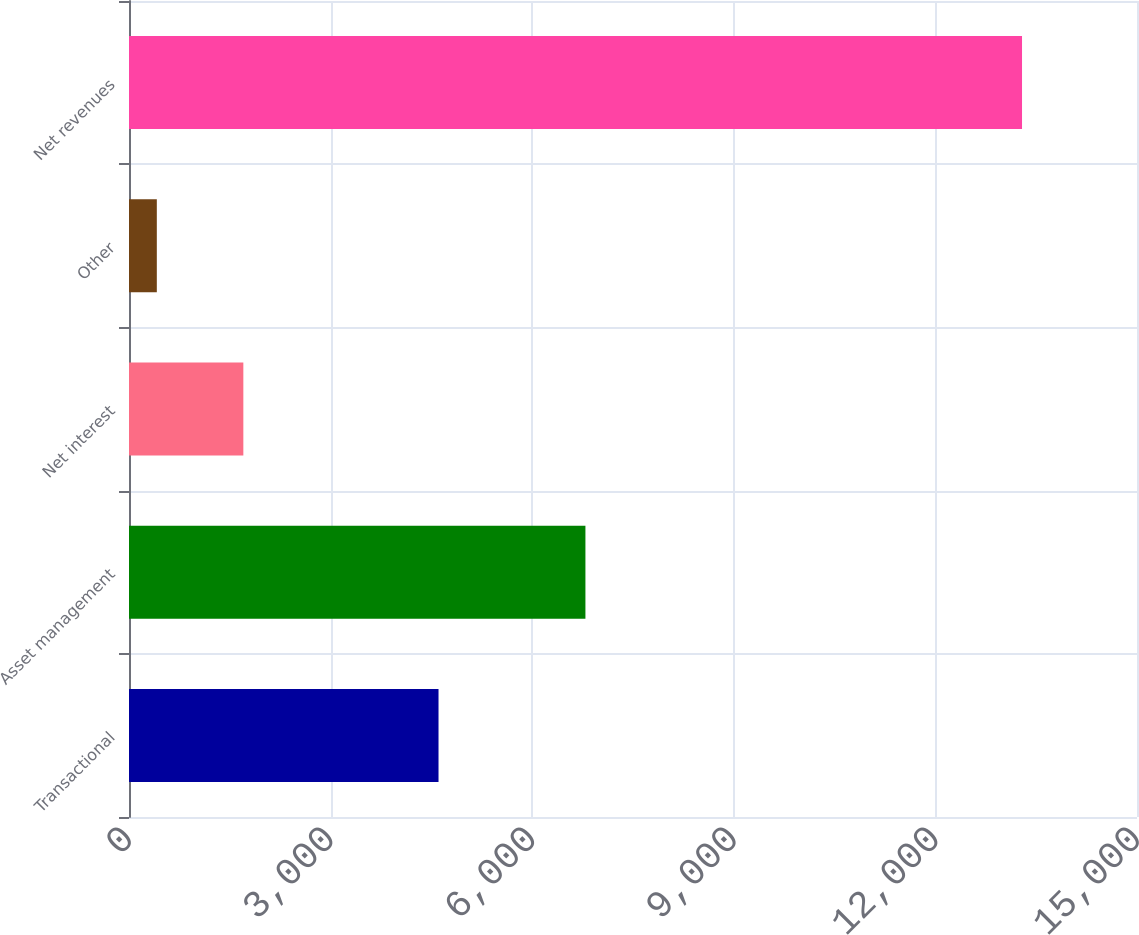<chart> <loc_0><loc_0><loc_500><loc_500><bar_chart><fcel>Transactional<fcel>Asset management<fcel>Net interest<fcel>Other<fcel>Net revenues<nl><fcel>4606<fcel>6792<fcel>1701.5<fcel>414<fcel>13289<nl></chart> 